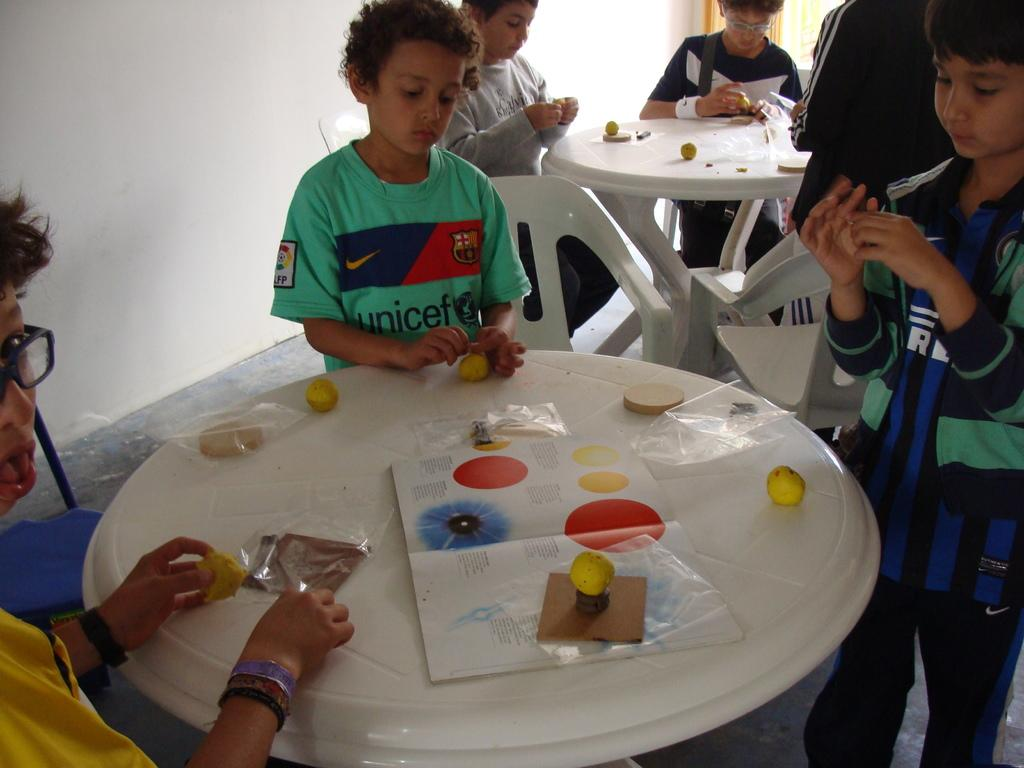What are the children doing in the image? The children are standing around tables in the image. How many chairs can be seen in the image? There are many chairs in the image. What items are on the table in the image? There are papers and books on the table in the image. What is visible in the background of the image? There is a wall in the background of the image. What color is the passenger's shirt in the image? There is no passenger present in the image, so it is not possible to determine the color of their shirt. 